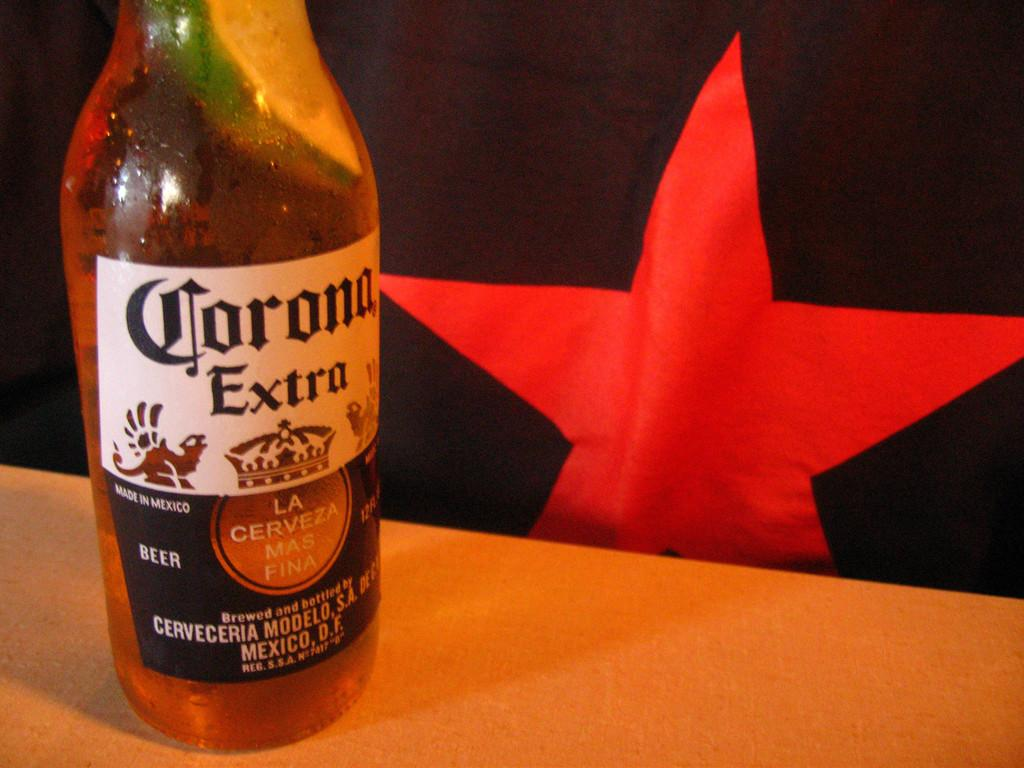What can be seen flying in the image? There is a flag in the image. What object is present that might contain a liquid? There is a bottle in the image. How many jellyfish are swimming near the flag in the image? There are no jellyfish present in the image. What type of conversation are the cows having in the image? There are no cows present in the image, so it is not possible to determine what type of conversation they might be having. 